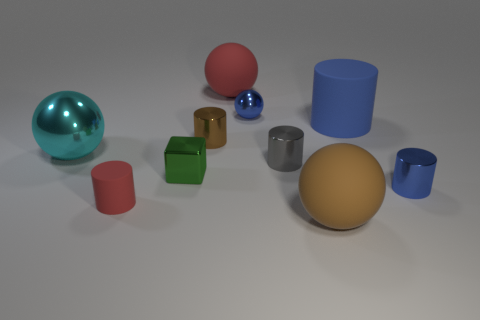There is a small blue metal thing that is behind the large blue rubber thing; what shape is it?
Keep it short and to the point. Sphere. Is there a tiny sphere that has the same color as the big metallic ball?
Offer a very short reply. No. How many large cyan matte spheres are there?
Ensure brevity in your answer.  0. There is a brown object that is in front of the big sphere that is left of the red matte thing that is behind the tiny rubber thing; what is it made of?
Offer a very short reply. Rubber. Is there a large cube made of the same material as the tiny block?
Keep it short and to the point. No. Is the material of the small blue cylinder the same as the tiny brown cylinder?
Offer a terse response. Yes. What number of spheres are tiny metallic things or small blue metal objects?
Keep it short and to the point. 1. There is a big thing that is made of the same material as the gray cylinder; what color is it?
Keep it short and to the point. Cyan. Are there fewer purple shiny things than large brown rubber objects?
Your response must be concise. Yes. There is a red rubber thing in front of the tiny metal block; is its shape the same as the tiny thing that is right of the large blue matte cylinder?
Make the answer very short. Yes. 